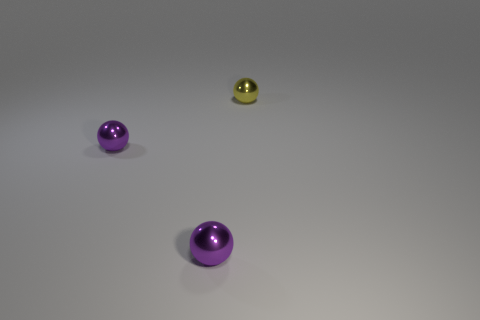What number of small purple balls are in front of the tiny yellow metal ball?
Provide a succinct answer. 2. Is there any other thing that is the same size as the yellow thing?
Provide a short and direct response. Yes. What number of things are either objects to the left of the small yellow metallic sphere or things in front of the tiny yellow object?
Your answer should be very brief. 2. Is the number of small purple metal balls that are behind the tiny yellow sphere greater than the number of tiny yellow spheres?
Give a very brief answer. No. How many other things are the same shape as the yellow shiny thing?
Ensure brevity in your answer.  2. What number of things are big red balls or metal spheres?
Your response must be concise. 3. Are there more metal spheres than yellow objects?
Ensure brevity in your answer.  Yes. What size is the yellow object?
Your answer should be very brief. Small. How many spheres are purple things or tiny yellow shiny things?
Ensure brevity in your answer.  3. How many metal spheres are there?
Provide a short and direct response. 3. 